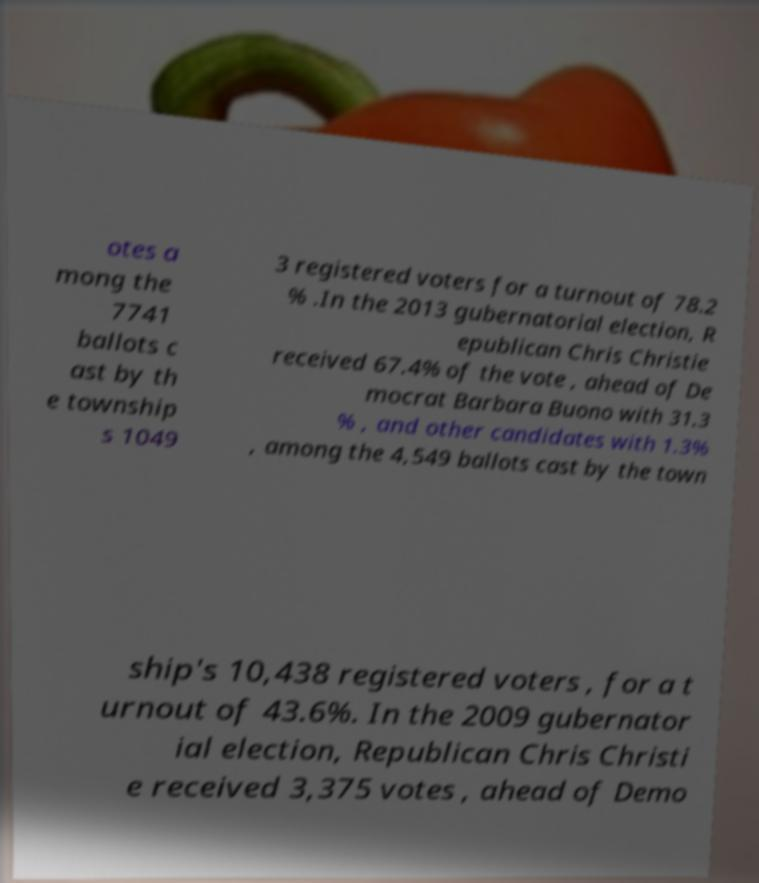Please identify and transcribe the text found in this image. otes a mong the 7741 ballots c ast by th e township s 1049 3 registered voters for a turnout of 78.2 % .In the 2013 gubernatorial election, R epublican Chris Christie received 67.4% of the vote , ahead of De mocrat Barbara Buono with 31.3 % , and other candidates with 1.3% , among the 4,549 ballots cast by the town ship's 10,438 registered voters , for a t urnout of 43.6%. In the 2009 gubernator ial election, Republican Chris Christi e received 3,375 votes , ahead of Demo 